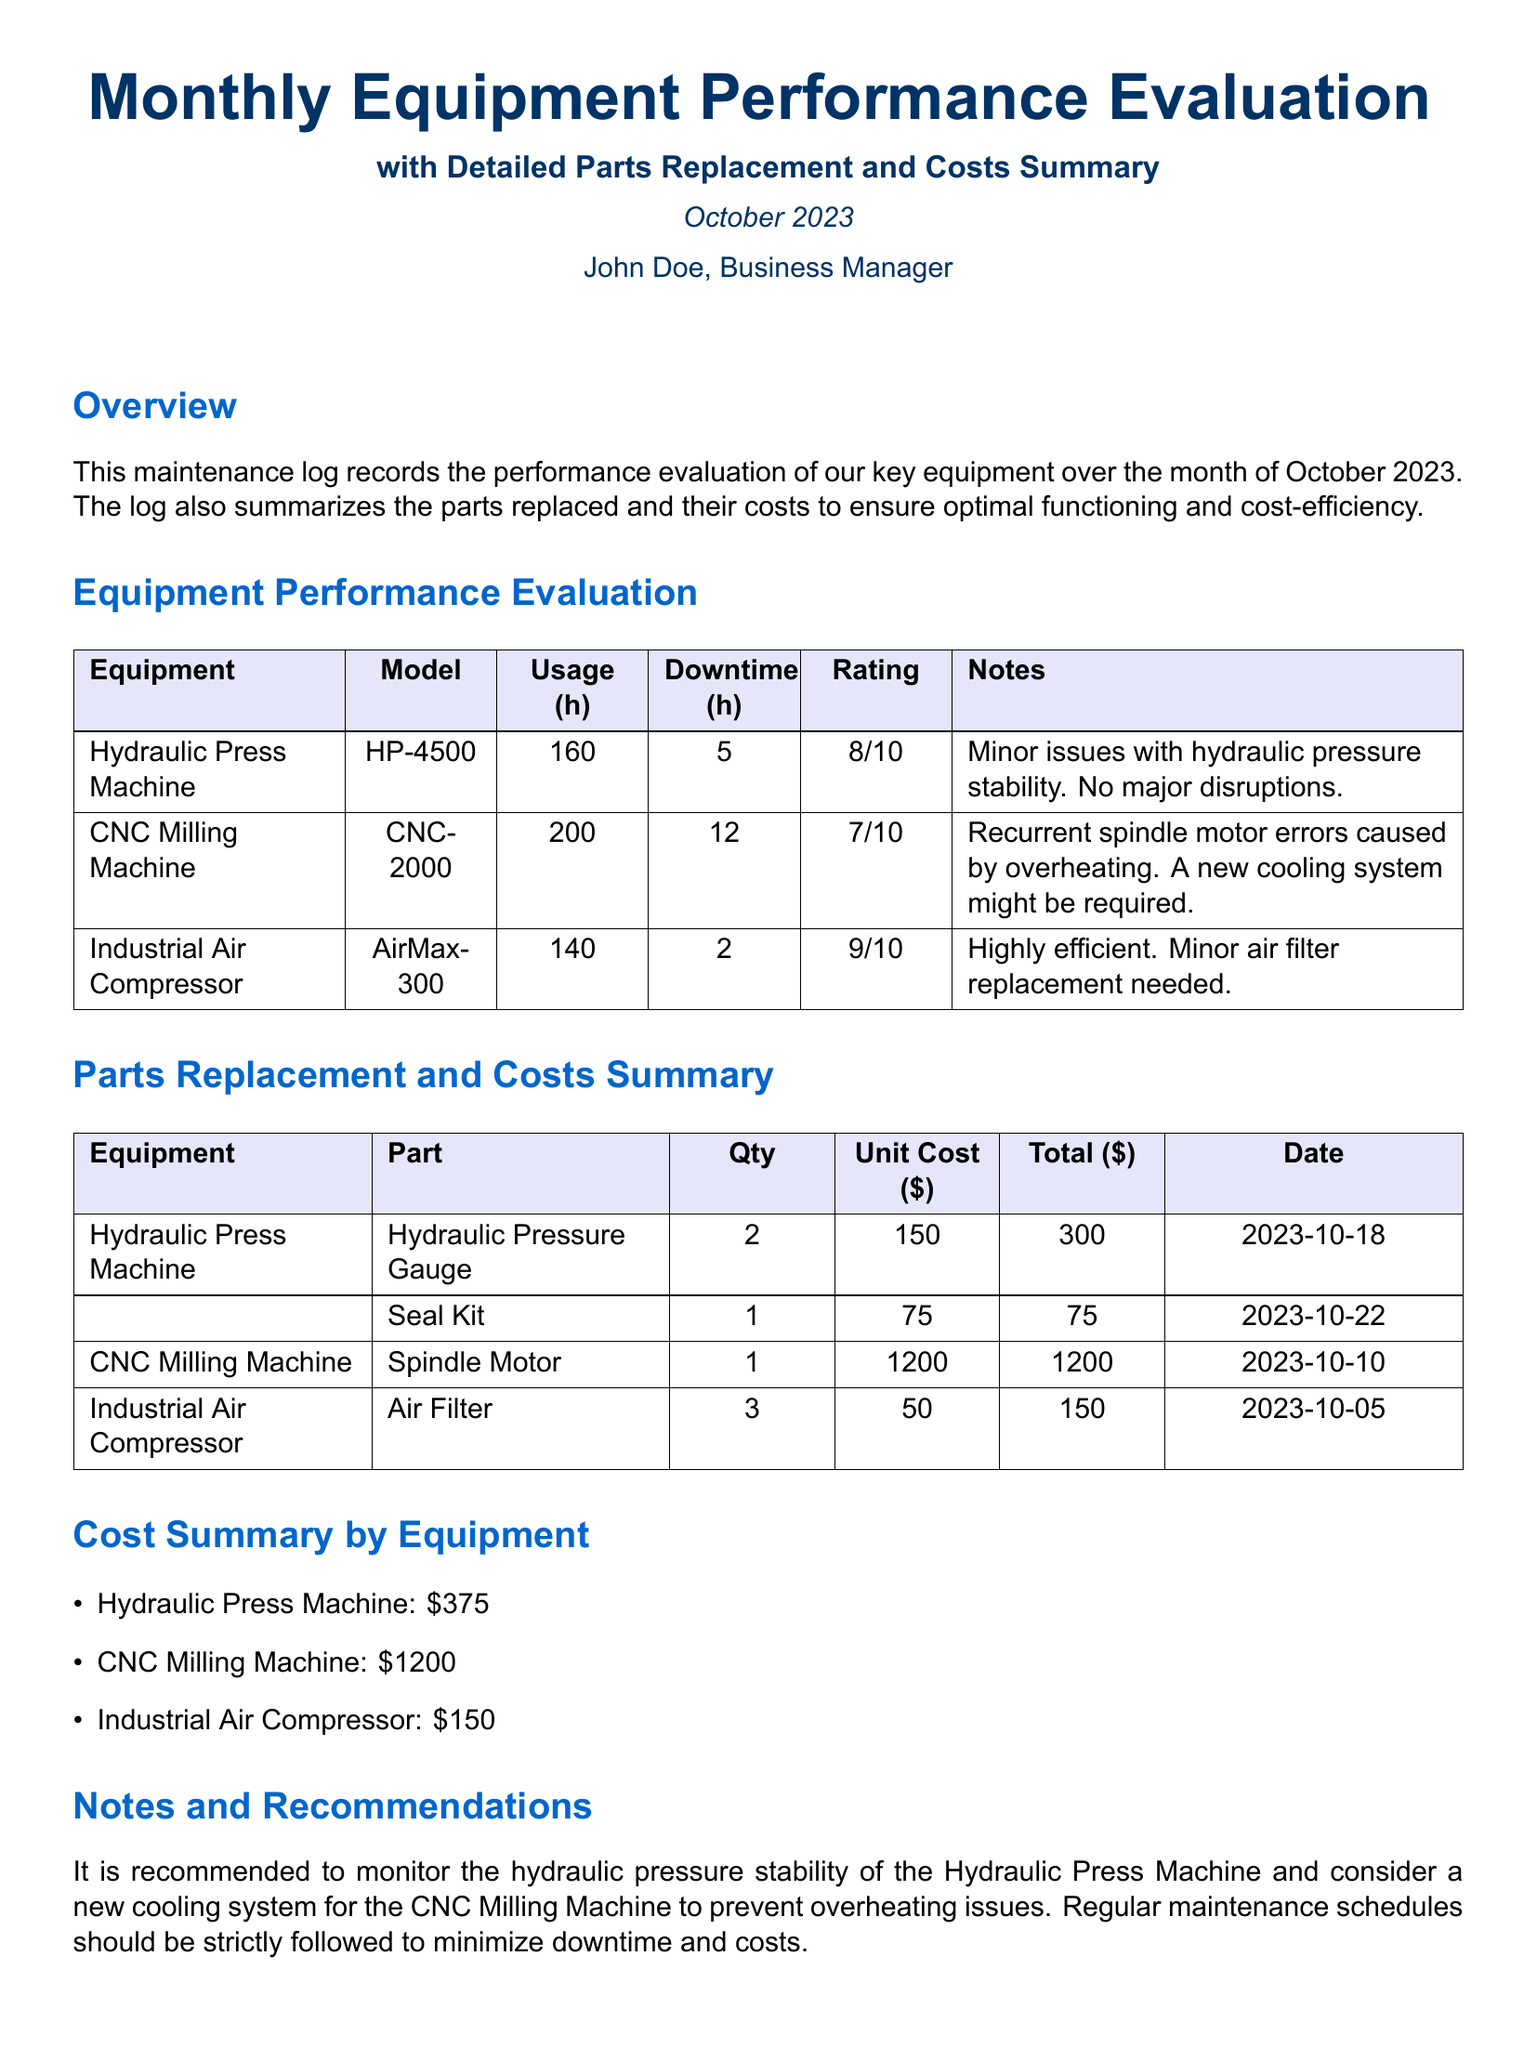What is the total downtime for the CNC Milling Machine? The total downtime for the CNC Milling Machine is explicitly listed in the document. It states that the downtime is 12 hours.
Answer: 12 h What is the rating of the Industrial Air Compressor? The document provides specific ratings for each piece of equipment, with the Industrial Air Compressor rated at 9 out of 10.
Answer: 9/10 Which part was replaced for the Hydraulic Press Machine on October 22, 2023? The document lists parts replaced along with the dates, identifying the Seal Kit as being replaced on October 22.
Answer: Seal Kit What is the total cost for parts replaced for the Hydraulic Press Machine? The document provides a summary of costs by equipment, indicating that the total cost for parts replaced for the Hydraulic Press Machine is 375 dollars.
Answer: $375 What recommendation is made for the CNC Milling Machine? The recommendations section provides insight into necessary actions, advising consideration of a new cooling system to prevent overheating issues.
Answer: New cooling system How many hours was the Industrial Air Compressor used? The usage hours are detailed for each equipment, citing that the Industrial Air Compressor was used for 140 hours.
Answer: 140 h What part was replaced on the Industrial Air Compressor? The parts replacement section identifies the Air Filter as the part that was replaced for the Industrial Air Compressor.
Answer: Air Filter What is the total cost for the CNC Milling Machine parts? The document summarizes the costs, specifically stating that the total for CNC Milling Machine parts is 1200 dollars.
Answer: $1200 What issue is noted for the Hydraulic Press Machine? The notes highlight a specific issue with the Hydraulic Press Machine regarding hydraulic pressure stability.
Answer: Hydraulic pressure stability 